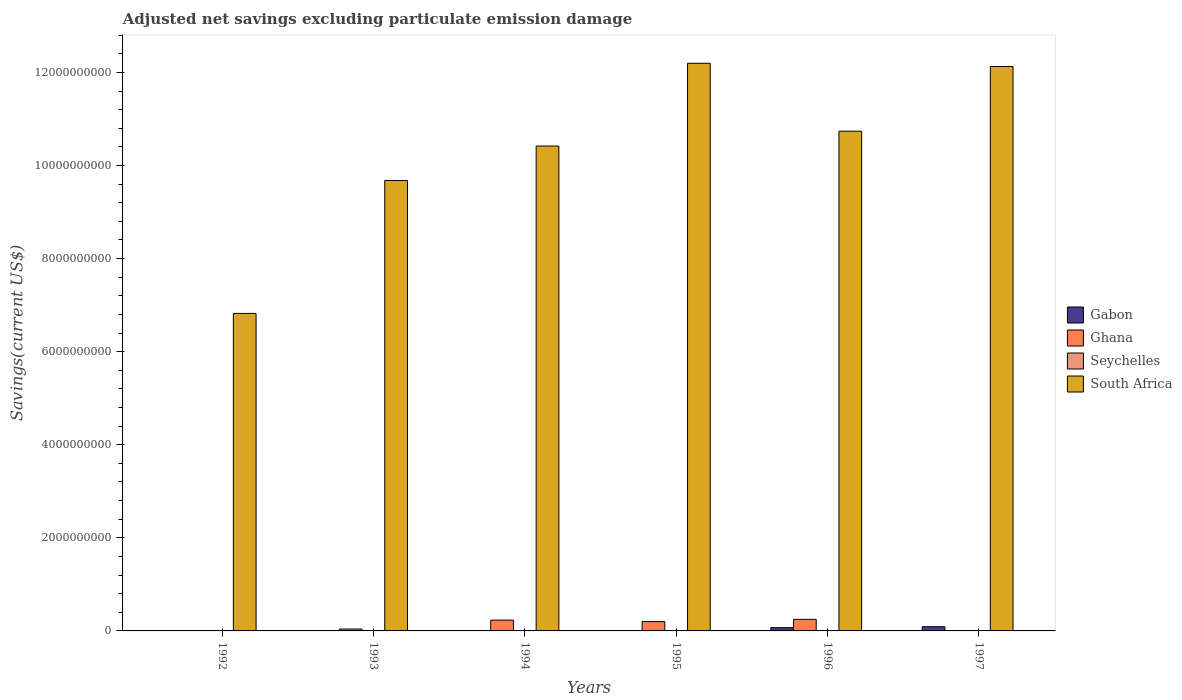How many different coloured bars are there?
Ensure brevity in your answer.  3. Are the number of bars on each tick of the X-axis equal?
Give a very brief answer. No. How many bars are there on the 1st tick from the left?
Ensure brevity in your answer.  1. In how many cases, is the number of bars for a given year not equal to the number of legend labels?
Provide a short and direct response. 6. Across all years, what is the maximum adjusted net savings in South Africa?
Offer a terse response. 1.22e+1. Across all years, what is the minimum adjusted net savings in South Africa?
Provide a succinct answer. 6.82e+09. What is the total adjusted net savings in Ghana in the graph?
Ensure brevity in your answer.  7.22e+08. What is the difference between the adjusted net savings in South Africa in 1992 and that in 1994?
Keep it short and to the point. -3.60e+09. What is the difference between the adjusted net savings in Ghana in 1996 and the adjusted net savings in Gabon in 1995?
Ensure brevity in your answer.  2.49e+08. What is the average adjusted net savings in Gabon per year?
Your answer should be very brief. 2.67e+07. In the year 1995, what is the difference between the adjusted net savings in Ghana and adjusted net savings in South Africa?
Keep it short and to the point. -1.20e+1. In how many years, is the adjusted net savings in Seychelles greater than 10800000000 US$?
Provide a short and direct response. 0. What is the ratio of the adjusted net savings in South Africa in 1992 to that in 1996?
Keep it short and to the point. 0.64. Is the adjusted net savings in South Africa in 1993 less than that in 1996?
Give a very brief answer. Yes. What is the difference between the highest and the second highest adjusted net savings in South Africa?
Your answer should be compact. 6.93e+07. What is the difference between the highest and the lowest adjusted net savings in South Africa?
Offer a terse response. 5.37e+09. In how many years, is the adjusted net savings in Gabon greater than the average adjusted net savings in Gabon taken over all years?
Your answer should be very brief. 2. Is it the case that in every year, the sum of the adjusted net savings in Seychelles and adjusted net savings in Ghana is greater than the sum of adjusted net savings in Gabon and adjusted net savings in South Africa?
Offer a terse response. No. Is it the case that in every year, the sum of the adjusted net savings in South Africa and adjusted net savings in Ghana is greater than the adjusted net savings in Gabon?
Your answer should be very brief. Yes. Are all the bars in the graph horizontal?
Ensure brevity in your answer.  No. How many years are there in the graph?
Give a very brief answer. 6. Are the values on the major ticks of Y-axis written in scientific E-notation?
Your answer should be very brief. No. Does the graph contain any zero values?
Offer a terse response. Yes. Does the graph contain grids?
Make the answer very short. No. Where does the legend appear in the graph?
Provide a short and direct response. Center right. How are the legend labels stacked?
Provide a short and direct response. Vertical. What is the title of the graph?
Offer a terse response. Adjusted net savings excluding particulate emission damage. Does "Pacific island small states" appear as one of the legend labels in the graph?
Your answer should be compact. No. What is the label or title of the X-axis?
Offer a terse response. Years. What is the label or title of the Y-axis?
Provide a short and direct response. Savings(current US$). What is the Savings(current US$) of Seychelles in 1992?
Your answer should be compact. 0. What is the Savings(current US$) of South Africa in 1992?
Offer a terse response. 6.82e+09. What is the Savings(current US$) in Ghana in 1993?
Keep it short and to the point. 4.06e+07. What is the Savings(current US$) of Seychelles in 1993?
Offer a very short reply. 0. What is the Savings(current US$) of South Africa in 1993?
Give a very brief answer. 9.68e+09. What is the Savings(current US$) of Ghana in 1994?
Your answer should be very brief. 2.32e+08. What is the Savings(current US$) in South Africa in 1994?
Make the answer very short. 1.04e+1. What is the Savings(current US$) of Ghana in 1995?
Your answer should be very brief. 2.00e+08. What is the Savings(current US$) in South Africa in 1995?
Your answer should be very brief. 1.22e+1. What is the Savings(current US$) in Gabon in 1996?
Your answer should be very brief. 7.02e+07. What is the Savings(current US$) in Ghana in 1996?
Your response must be concise. 2.49e+08. What is the Savings(current US$) in South Africa in 1996?
Provide a succinct answer. 1.07e+1. What is the Savings(current US$) of Gabon in 1997?
Provide a short and direct response. 9.02e+07. What is the Savings(current US$) of Ghana in 1997?
Make the answer very short. 0. What is the Savings(current US$) of South Africa in 1997?
Keep it short and to the point. 1.21e+1. Across all years, what is the maximum Savings(current US$) in Gabon?
Make the answer very short. 9.02e+07. Across all years, what is the maximum Savings(current US$) in Ghana?
Keep it short and to the point. 2.49e+08. Across all years, what is the maximum Savings(current US$) of South Africa?
Your response must be concise. 1.22e+1. Across all years, what is the minimum Savings(current US$) in South Africa?
Ensure brevity in your answer.  6.82e+09. What is the total Savings(current US$) in Gabon in the graph?
Keep it short and to the point. 1.60e+08. What is the total Savings(current US$) in Ghana in the graph?
Keep it short and to the point. 7.22e+08. What is the total Savings(current US$) of South Africa in the graph?
Provide a succinct answer. 6.20e+1. What is the difference between the Savings(current US$) of South Africa in 1992 and that in 1993?
Offer a very short reply. -2.86e+09. What is the difference between the Savings(current US$) of South Africa in 1992 and that in 1994?
Offer a terse response. -3.60e+09. What is the difference between the Savings(current US$) of South Africa in 1992 and that in 1995?
Your answer should be compact. -5.37e+09. What is the difference between the Savings(current US$) in South Africa in 1992 and that in 1996?
Give a very brief answer. -3.92e+09. What is the difference between the Savings(current US$) of South Africa in 1992 and that in 1997?
Keep it short and to the point. -5.31e+09. What is the difference between the Savings(current US$) of Ghana in 1993 and that in 1994?
Ensure brevity in your answer.  -1.91e+08. What is the difference between the Savings(current US$) in South Africa in 1993 and that in 1994?
Keep it short and to the point. -7.41e+08. What is the difference between the Savings(current US$) in Ghana in 1993 and that in 1995?
Your answer should be compact. -1.60e+08. What is the difference between the Savings(current US$) of South Africa in 1993 and that in 1995?
Your answer should be compact. -2.52e+09. What is the difference between the Savings(current US$) of Ghana in 1993 and that in 1996?
Provide a succinct answer. -2.08e+08. What is the difference between the Savings(current US$) in South Africa in 1993 and that in 1996?
Your answer should be compact. -1.06e+09. What is the difference between the Savings(current US$) of South Africa in 1993 and that in 1997?
Ensure brevity in your answer.  -2.45e+09. What is the difference between the Savings(current US$) of Ghana in 1994 and that in 1995?
Keep it short and to the point. 3.18e+07. What is the difference between the Savings(current US$) of South Africa in 1994 and that in 1995?
Offer a very short reply. -1.78e+09. What is the difference between the Savings(current US$) in Ghana in 1994 and that in 1996?
Your response must be concise. -1.71e+07. What is the difference between the Savings(current US$) of South Africa in 1994 and that in 1996?
Provide a succinct answer. -3.19e+08. What is the difference between the Savings(current US$) in South Africa in 1994 and that in 1997?
Your answer should be very brief. -1.71e+09. What is the difference between the Savings(current US$) of Ghana in 1995 and that in 1996?
Provide a short and direct response. -4.89e+07. What is the difference between the Savings(current US$) in South Africa in 1995 and that in 1996?
Your response must be concise. 1.46e+09. What is the difference between the Savings(current US$) in South Africa in 1995 and that in 1997?
Provide a short and direct response. 6.93e+07. What is the difference between the Savings(current US$) in Gabon in 1996 and that in 1997?
Offer a terse response. -2.00e+07. What is the difference between the Savings(current US$) in South Africa in 1996 and that in 1997?
Offer a very short reply. -1.39e+09. What is the difference between the Savings(current US$) in Ghana in 1993 and the Savings(current US$) in South Africa in 1994?
Offer a very short reply. -1.04e+1. What is the difference between the Savings(current US$) of Ghana in 1993 and the Savings(current US$) of South Africa in 1995?
Offer a very short reply. -1.22e+1. What is the difference between the Savings(current US$) of Ghana in 1993 and the Savings(current US$) of South Africa in 1996?
Ensure brevity in your answer.  -1.07e+1. What is the difference between the Savings(current US$) of Ghana in 1993 and the Savings(current US$) of South Africa in 1997?
Keep it short and to the point. -1.21e+1. What is the difference between the Savings(current US$) of Ghana in 1994 and the Savings(current US$) of South Africa in 1995?
Your answer should be very brief. -1.20e+1. What is the difference between the Savings(current US$) of Ghana in 1994 and the Savings(current US$) of South Africa in 1996?
Provide a succinct answer. -1.05e+1. What is the difference between the Savings(current US$) in Ghana in 1994 and the Savings(current US$) in South Africa in 1997?
Make the answer very short. -1.19e+1. What is the difference between the Savings(current US$) in Ghana in 1995 and the Savings(current US$) in South Africa in 1996?
Make the answer very short. -1.05e+1. What is the difference between the Savings(current US$) in Ghana in 1995 and the Savings(current US$) in South Africa in 1997?
Offer a very short reply. -1.19e+1. What is the difference between the Savings(current US$) in Gabon in 1996 and the Savings(current US$) in South Africa in 1997?
Offer a terse response. -1.21e+1. What is the difference between the Savings(current US$) of Ghana in 1996 and the Savings(current US$) of South Africa in 1997?
Make the answer very short. -1.19e+1. What is the average Savings(current US$) of Gabon per year?
Provide a succinct answer. 2.67e+07. What is the average Savings(current US$) of Ghana per year?
Provide a succinct answer. 1.20e+08. What is the average Savings(current US$) in South Africa per year?
Give a very brief answer. 1.03e+1. In the year 1993, what is the difference between the Savings(current US$) in Ghana and Savings(current US$) in South Africa?
Your response must be concise. -9.64e+09. In the year 1994, what is the difference between the Savings(current US$) in Ghana and Savings(current US$) in South Africa?
Your answer should be very brief. -1.02e+1. In the year 1995, what is the difference between the Savings(current US$) of Ghana and Savings(current US$) of South Africa?
Your response must be concise. -1.20e+1. In the year 1996, what is the difference between the Savings(current US$) of Gabon and Savings(current US$) of Ghana?
Give a very brief answer. -1.79e+08. In the year 1996, what is the difference between the Savings(current US$) in Gabon and Savings(current US$) in South Africa?
Make the answer very short. -1.07e+1. In the year 1996, what is the difference between the Savings(current US$) in Ghana and Savings(current US$) in South Africa?
Provide a short and direct response. -1.05e+1. In the year 1997, what is the difference between the Savings(current US$) of Gabon and Savings(current US$) of South Africa?
Your answer should be very brief. -1.20e+1. What is the ratio of the Savings(current US$) in South Africa in 1992 to that in 1993?
Keep it short and to the point. 0.7. What is the ratio of the Savings(current US$) in South Africa in 1992 to that in 1994?
Ensure brevity in your answer.  0.65. What is the ratio of the Savings(current US$) of South Africa in 1992 to that in 1995?
Keep it short and to the point. 0.56. What is the ratio of the Savings(current US$) of South Africa in 1992 to that in 1996?
Your answer should be compact. 0.64. What is the ratio of the Savings(current US$) of South Africa in 1992 to that in 1997?
Ensure brevity in your answer.  0.56. What is the ratio of the Savings(current US$) in Ghana in 1993 to that in 1994?
Make the answer very short. 0.17. What is the ratio of the Savings(current US$) of South Africa in 1993 to that in 1994?
Give a very brief answer. 0.93. What is the ratio of the Savings(current US$) in Ghana in 1993 to that in 1995?
Make the answer very short. 0.2. What is the ratio of the Savings(current US$) of South Africa in 1993 to that in 1995?
Offer a terse response. 0.79. What is the ratio of the Savings(current US$) of Ghana in 1993 to that in 1996?
Ensure brevity in your answer.  0.16. What is the ratio of the Savings(current US$) in South Africa in 1993 to that in 1996?
Ensure brevity in your answer.  0.9. What is the ratio of the Savings(current US$) of South Africa in 1993 to that in 1997?
Your answer should be very brief. 0.8. What is the ratio of the Savings(current US$) of Ghana in 1994 to that in 1995?
Give a very brief answer. 1.16. What is the ratio of the Savings(current US$) in South Africa in 1994 to that in 1995?
Offer a very short reply. 0.85. What is the ratio of the Savings(current US$) in Ghana in 1994 to that in 1996?
Give a very brief answer. 0.93. What is the ratio of the Savings(current US$) in South Africa in 1994 to that in 1996?
Keep it short and to the point. 0.97. What is the ratio of the Savings(current US$) in South Africa in 1994 to that in 1997?
Keep it short and to the point. 0.86. What is the ratio of the Savings(current US$) in Ghana in 1995 to that in 1996?
Provide a short and direct response. 0.8. What is the ratio of the Savings(current US$) of South Africa in 1995 to that in 1996?
Offer a very short reply. 1.14. What is the ratio of the Savings(current US$) in Gabon in 1996 to that in 1997?
Make the answer very short. 0.78. What is the ratio of the Savings(current US$) in South Africa in 1996 to that in 1997?
Provide a short and direct response. 0.89. What is the difference between the highest and the second highest Savings(current US$) in Ghana?
Give a very brief answer. 1.71e+07. What is the difference between the highest and the second highest Savings(current US$) of South Africa?
Ensure brevity in your answer.  6.93e+07. What is the difference between the highest and the lowest Savings(current US$) of Gabon?
Keep it short and to the point. 9.02e+07. What is the difference between the highest and the lowest Savings(current US$) of Ghana?
Provide a succinct answer. 2.49e+08. What is the difference between the highest and the lowest Savings(current US$) of South Africa?
Offer a terse response. 5.37e+09. 